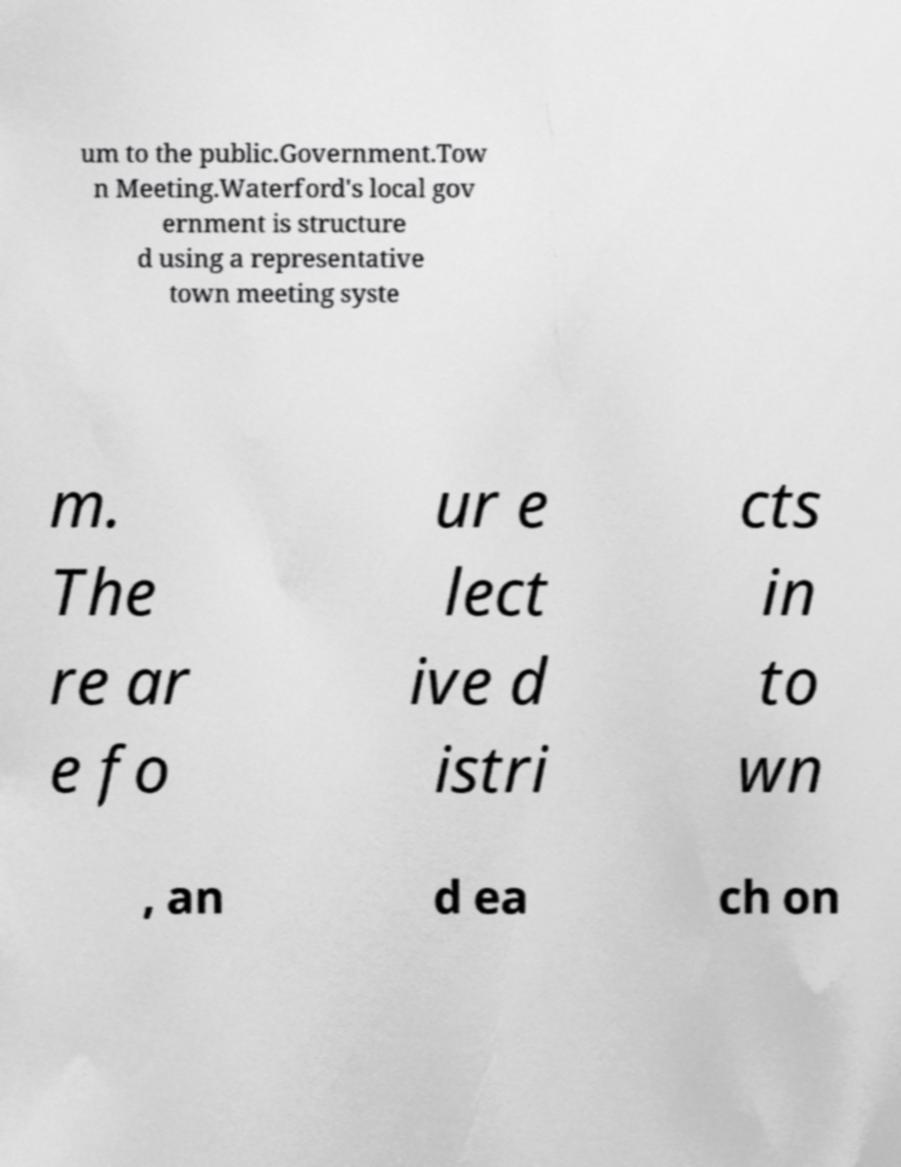There's text embedded in this image that I need extracted. Can you transcribe it verbatim? um to the public.Government.Tow n Meeting.Waterford's local gov ernment is structure d using a representative town meeting syste m. The re ar e fo ur e lect ive d istri cts in to wn , an d ea ch on 